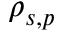<formula> <loc_0><loc_0><loc_500><loc_500>\rho _ { s , p }</formula> 